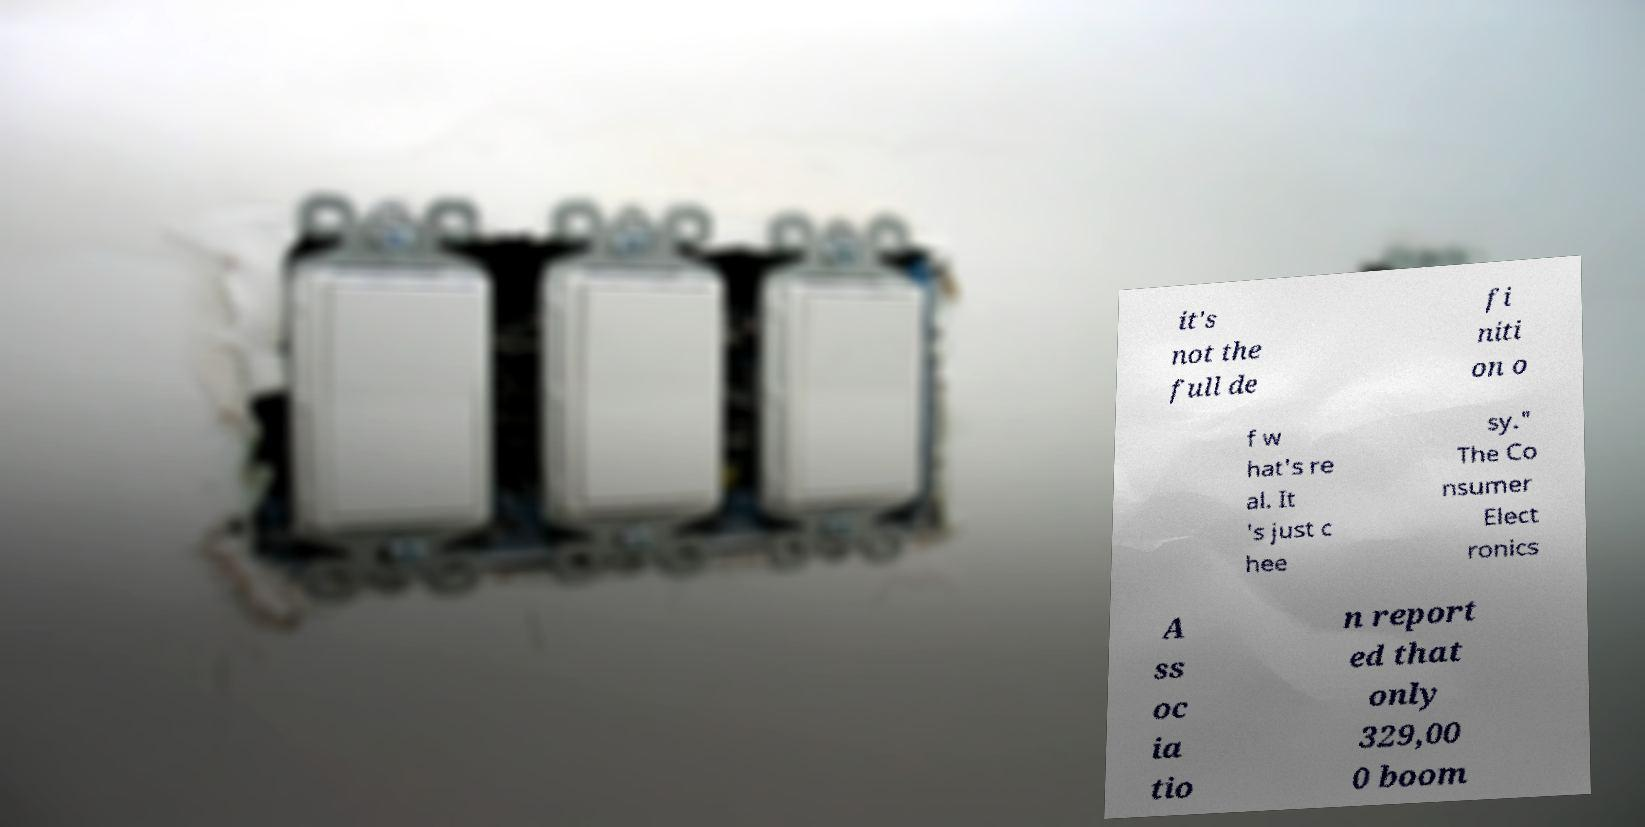Can you read and provide the text displayed in the image?This photo seems to have some interesting text. Can you extract and type it out for me? it's not the full de fi niti on o f w hat's re al. It 's just c hee sy." The Co nsumer Elect ronics A ss oc ia tio n report ed that only 329,00 0 boom 